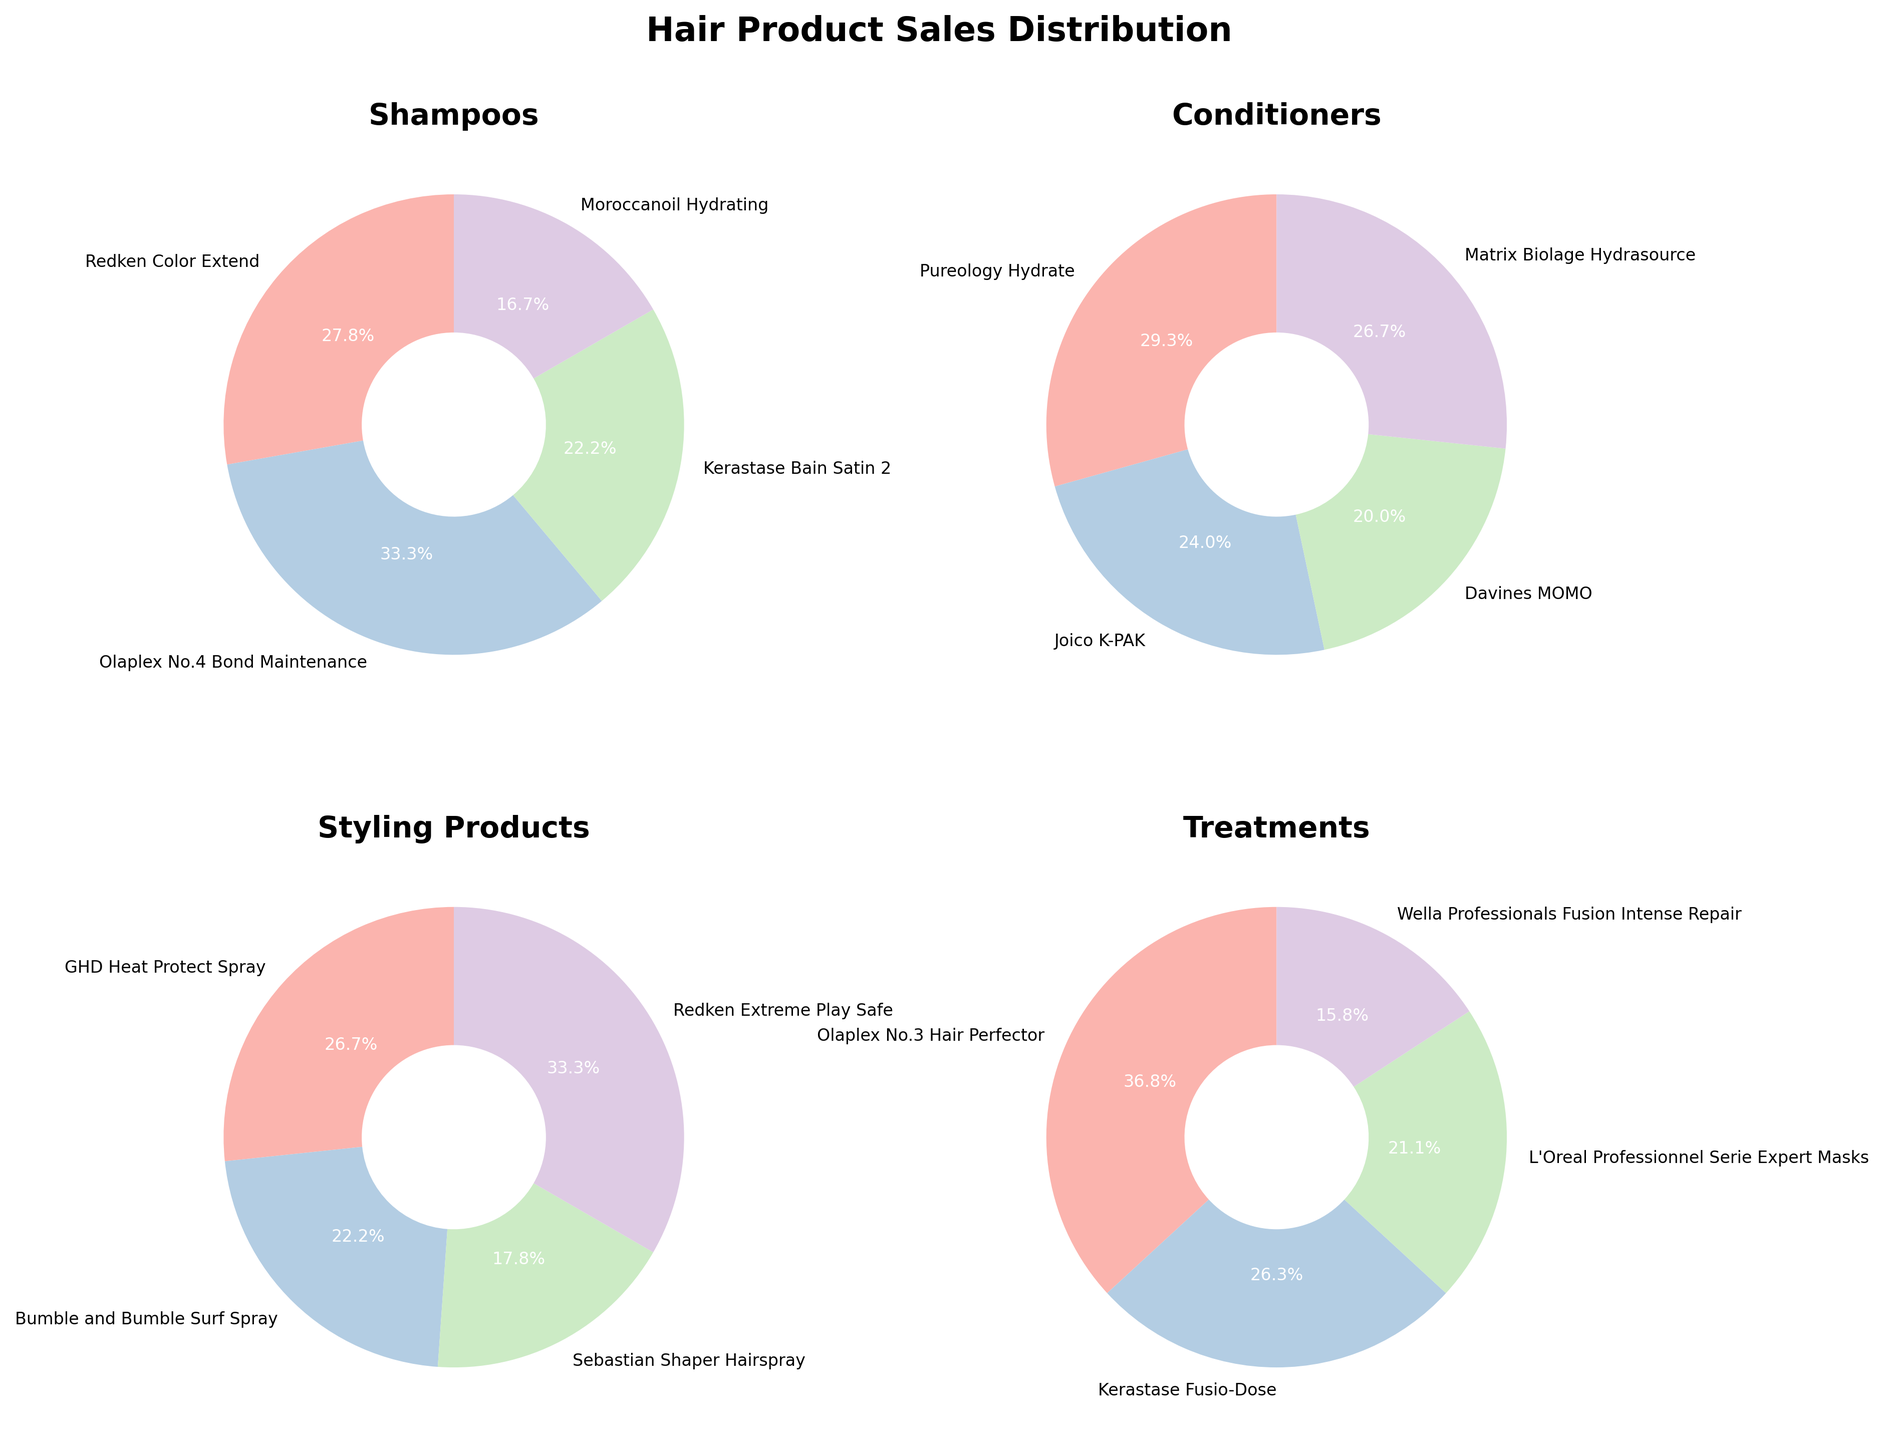What is the title of the figure? The title is located at the top center of the figure, which summarizes the content of the plot.
Answer: Hair Product Sales Distribution Which shampoo has the highest sales? Locate the pie chart titled "Shampoos" and identify the product label with the largest slice of the pie chart.
Answer: Olaplex No.4 Bond Maintenance How much percentage does Redken Color Extend Shampoo contribute to total shampoo sales? Find the Redken Color Extend section in the "Shampoos" pie chart and read the percentage displayed.
Answer: 25.0% Which category has the highest individual product sales? Compare the maximum percentage slices from each of the four pie charts and identify the highest one.
Answer: Treatments What is the combined percentage of Pureology Hydrate and Joico K-PAK conditioners? Add the percentages of Pureology Hydrate and Joico K-PAK from the "Conditioners" pie chart.
Answer: 55.0% Which category has the smallest product slice and what product is it? Look for the smallest segment in each pie chart and identify the respective product and category.
Answer: Styling Products, Sebastian Shaper Hairspray Which treatment product holds the largest market share within its category? Identify the largest segment in the "Treatments" pie chart.
Answer: Olaplex No.3 Hair Perfector Compare the sales percentages of GHD Heat Protect Spray and Bumble and Bumble Surf Spray from the styling products category. Which one has higher sales? Locate the segments for both GHD Heat Protect Spray and Bumble and Bumble Surf Spray in the "Styling Products" pie chart and compare their percentages.
Answer: GHD Heat Protect Spray What is the proportion of the two lowest-selling products within the Treatments category combined? Identify and sum the percentages of the two smallest slices in the "Treatments" pie chart.
Answer: 55.6% Which products have a sales percentage of exactly 20% in their respective categories? Scan through each pie chart to identify the products with slices labeled as 20%.
Answer: Kerastase Bain Satin 2 (Shampoos), Matrix Biolage Hydrasource (Conditioners), L'Oreal Professionnel Serie Expert Masks (Treatments) 